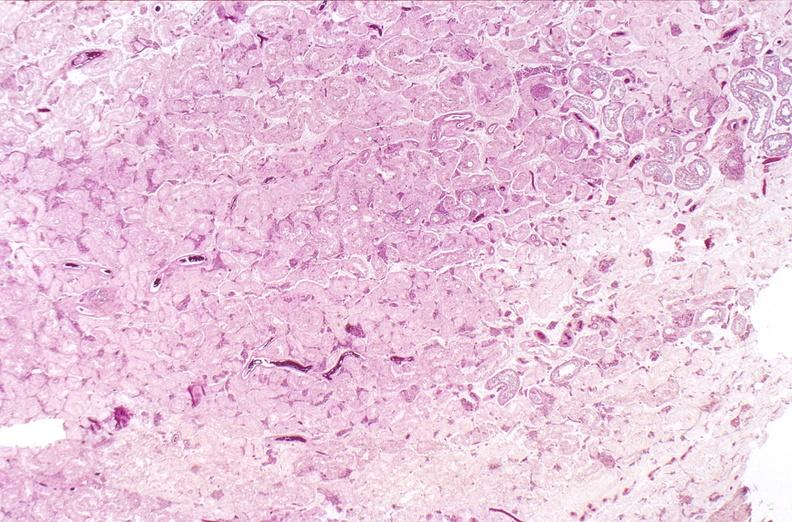does this image show testes, testicular atrophy?
Answer the question using a single word or phrase. Yes 